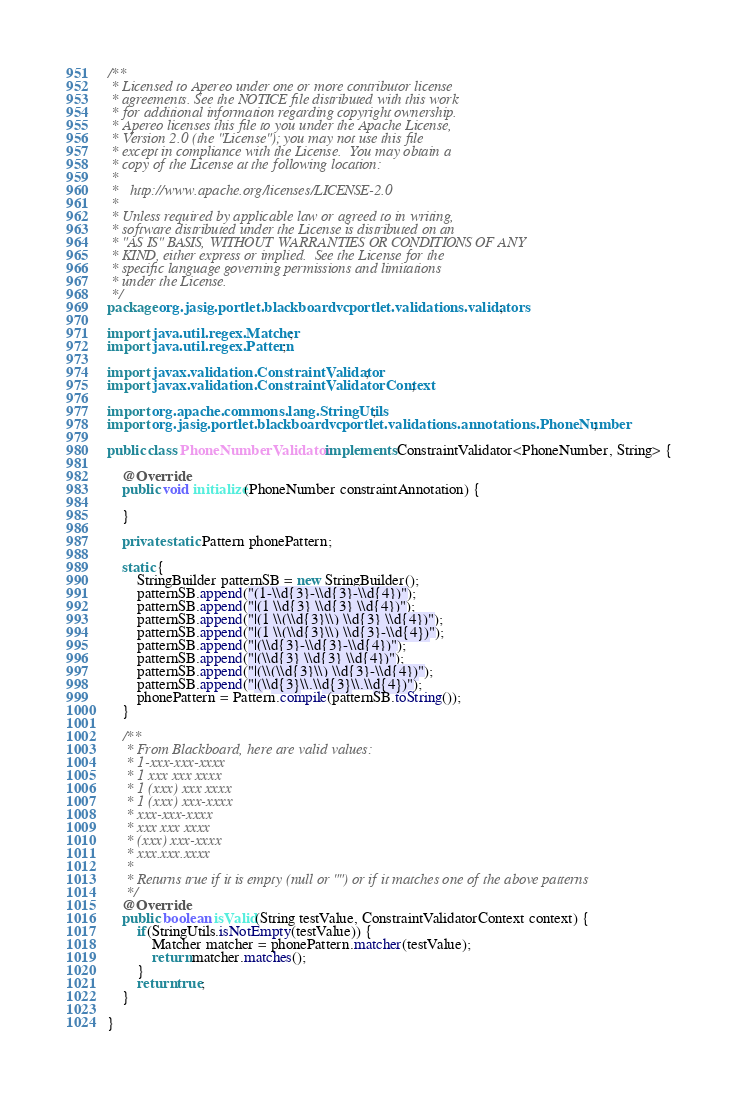Convert code to text. <code><loc_0><loc_0><loc_500><loc_500><_Java_>/**
 * Licensed to Apereo under one or more contributor license
 * agreements. See the NOTICE file distributed with this work
 * for additional information regarding copyright ownership.
 * Apereo licenses this file to you under the Apache License,
 * Version 2.0 (the "License"); you may not use this file
 * except in compliance with the License.  You may obtain a
 * copy of the License at the following location:
 *
 *   http://www.apache.org/licenses/LICENSE-2.0
 *
 * Unless required by applicable law or agreed to in writing,
 * software distributed under the License is distributed on an
 * "AS IS" BASIS, WITHOUT WARRANTIES OR CONDITIONS OF ANY
 * KIND, either express or implied.  See the License for the
 * specific language governing permissions and limitations
 * under the License.
 */
package org.jasig.portlet.blackboardvcportlet.validations.validators;

import java.util.regex.Matcher;
import java.util.regex.Pattern;

import javax.validation.ConstraintValidator;
import javax.validation.ConstraintValidatorContext;

import org.apache.commons.lang.StringUtils;
import org.jasig.portlet.blackboardvcportlet.validations.annotations.PhoneNumber;

public class PhoneNumberValidator implements ConstraintValidator<PhoneNumber, String> {

    @Override
    public void initialize(PhoneNumber constraintAnnotation) {
        
    }
 
    private static Pattern phonePattern;

    static {
        StringBuilder patternSB = new StringBuilder();
        patternSB.append("(1-\\d{3}-\\d{3}-\\d{4})");
        patternSB.append("|(1 \\d{3} \\d{3} \\d{4})");
        patternSB.append("|(1 \\(\\d{3}\\) \\d{3} \\d{4})");
        patternSB.append("|(1 \\(\\d{3}\\) \\d{3}-\\d{4})");
        patternSB.append("|(\\d{3}-\\d{3}-\\d{4})");
        patternSB.append("|(\\d{3} \\d{3} \\d{4})");
        patternSB.append("|(\\(\\d{3}\\) \\d{3}-\\d{4})");
        patternSB.append("|(\\d{3}\\.\\d{3}\\.\\d{4})");
        phonePattern = Pattern.compile(patternSB.toString());
    }
    
    /**
     * From Blackboard, here are valid values:
     * 1-xxx-xxx-xxxx
     * 1 xxx xxx xxxx
     * 1 (xxx) xxx xxxx
     * 1 (xxx) xxx-xxxx
     * xxx-xxx-xxxx
     * xxx xxx xxxx
     * (xxx) xxx-xxxx
     * xxx.xxx.xxxx
     * 
     * Returns true if it is empty (null or "") or if it matches one of the above patterns
     */
    @Override
    public boolean isValid(String testValue, ConstraintValidatorContext context) {
        if(StringUtils.isNotEmpty(testValue)) {
            Matcher matcher = phonePattern.matcher(testValue);
            return matcher.matches();
        } 
        return true;
    }

}
</code> 